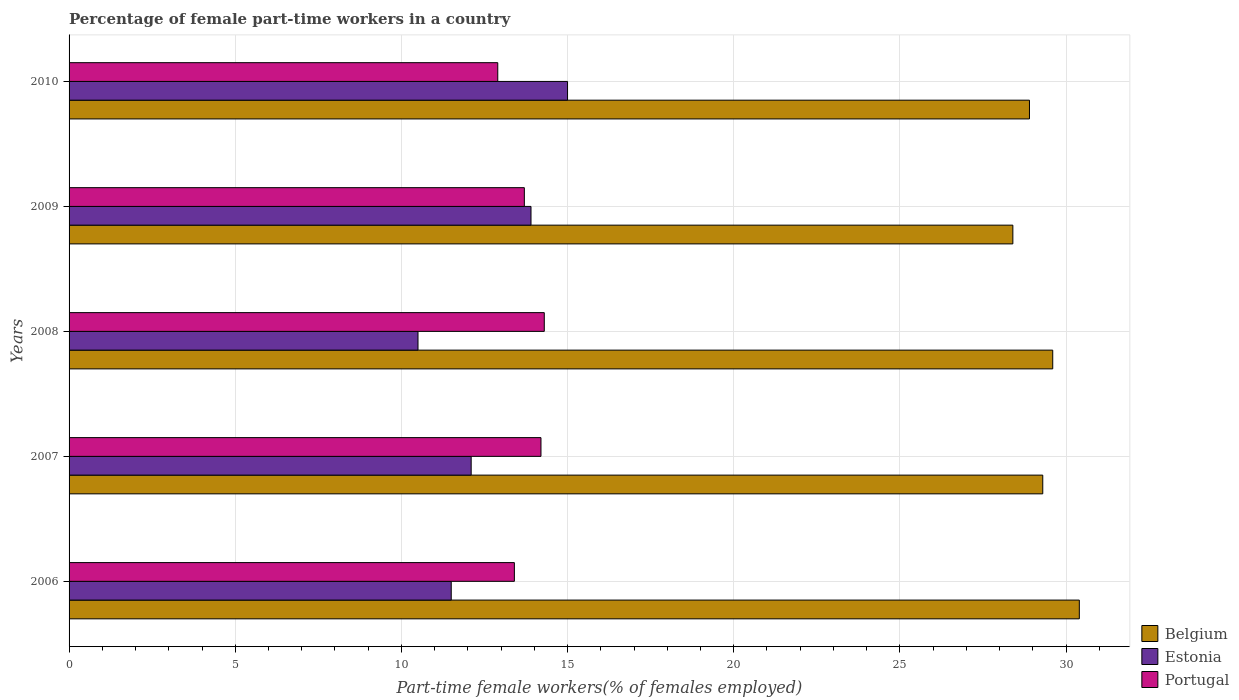Are the number of bars per tick equal to the number of legend labels?
Make the answer very short. Yes. Are the number of bars on each tick of the Y-axis equal?
Your answer should be compact. Yes. How many bars are there on the 1st tick from the bottom?
Give a very brief answer. 3. What is the percentage of female part-time workers in Portugal in 2010?
Your response must be concise. 12.9. Across all years, what is the maximum percentage of female part-time workers in Portugal?
Offer a terse response. 14.3. Across all years, what is the minimum percentage of female part-time workers in Portugal?
Your answer should be very brief. 12.9. In which year was the percentage of female part-time workers in Portugal maximum?
Provide a succinct answer. 2008. What is the total percentage of female part-time workers in Portugal in the graph?
Give a very brief answer. 68.5. What is the difference between the percentage of female part-time workers in Belgium in 2007 and that in 2010?
Offer a terse response. 0.4. What is the difference between the percentage of female part-time workers in Portugal in 2010 and the percentage of female part-time workers in Belgium in 2008?
Offer a terse response. -16.7. What is the average percentage of female part-time workers in Portugal per year?
Give a very brief answer. 13.7. In the year 2007, what is the difference between the percentage of female part-time workers in Portugal and percentage of female part-time workers in Estonia?
Your response must be concise. 2.1. What is the ratio of the percentage of female part-time workers in Estonia in 2007 to that in 2009?
Provide a short and direct response. 0.87. Is the percentage of female part-time workers in Estonia in 2008 less than that in 2009?
Your answer should be compact. Yes. Is the difference between the percentage of female part-time workers in Portugal in 2006 and 2009 greater than the difference between the percentage of female part-time workers in Estonia in 2006 and 2009?
Provide a short and direct response. Yes. What is the difference between the highest and the second highest percentage of female part-time workers in Estonia?
Offer a terse response. 1.1. What is the difference between the highest and the lowest percentage of female part-time workers in Portugal?
Your response must be concise. 1.4. What does the 1st bar from the top in 2008 represents?
Keep it short and to the point. Portugal. What does the 1st bar from the bottom in 2006 represents?
Provide a succinct answer. Belgium. Is it the case that in every year, the sum of the percentage of female part-time workers in Belgium and percentage of female part-time workers in Estonia is greater than the percentage of female part-time workers in Portugal?
Offer a very short reply. Yes. How many bars are there?
Offer a terse response. 15. Are all the bars in the graph horizontal?
Ensure brevity in your answer.  Yes. How many years are there in the graph?
Offer a terse response. 5. What is the difference between two consecutive major ticks on the X-axis?
Offer a terse response. 5. Are the values on the major ticks of X-axis written in scientific E-notation?
Ensure brevity in your answer.  No. Does the graph contain grids?
Your response must be concise. Yes. How are the legend labels stacked?
Your response must be concise. Vertical. What is the title of the graph?
Your response must be concise. Percentage of female part-time workers in a country. What is the label or title of the X-axis?
Provide a succinct answer. Part-time female workers(% of females employed). What is the label or title of the Y-axis?
Give a very brief answer. Years. What is the Part-time female workers(% of females employed) of Belgium in 2006?
Your response must be concise. 30.4. What is the Part-time female workers(% of females employed) in Estonia in 2006?
Ensure brevity in your answer.  11.5. What is the Part-time female workers(% of females employed) in Portugal in 2006?
Your answer should be compact. 13.4. What is the Part-time female workers(% of females employed) of Belgium in 2007?
Your answer should be compact. 29.3. What is the Part-time female workers(% of females employed) of Estonia in 2007?
Make the answer very short. 12.1. What is the Part-time female workers(% of females employed) in Portugal in 2007?
Offer a terse response. 14.2. What is the Part-time female workers(% of females employed) in Belgium in 2008?
Provide a succinct answer. 29.6. What is the Part-time female workers(% of females employed) of Portugal in 2008?
Your response must be concise. 14.3. What is the Part-time female workers(% of females employed) of Belgium in 2009?
Provide a succinct answer. 28.4. What is the Part-time female workers(% of females employed) in Estonia in 2009?
Provide a short and direct response. 13.9. What is the Part-time female workers(% of females employed) in Portugal in 2009?
Offer a very short reply. 13.7. What is the Part-time female workers(% of females employed) in Belgium in 2010?
Offer a terse response. 28.9. What is the Part-time female workers(% of females employed) of Estonia in 2010?
Offer a very short reply. 15. What is the Part-time female workers(% of females employed) of Portugal in 2010?
Ensure brevity in your answer.  12.9. Across all years, what is the maximum Part-time female workers(% of females employed) in Belgium?
Ensure brevity in your answer.  30.4. Across all years, what is the maximum Part-time female workers(% of females employed) in Portugal?
Give a very brief answer. 14.3. Across all years, what is the minimum Part-time female workers(% of females employed) of Belgium?
Provide a short and direct response. 28.4. Across all years, what is the minimum Part-time female workers(% of females employed) in Estonia?
Offer a terse response. 10.5. Across all years, what is the minimum Part-time female workers(% of females employed) of Portugal?
Offer a very short reply. 12.9. What is the total Part-time female workers(% of females employed) in Belgium in the graph?
Your answer should be compact. 146.6. What is the total Part-time female workers(% of females employed) in Portugal in the graph?
Give a very brief answer. 68.5. What is the difference between the Part-time female workers(% of females employed) in Belgium in 2006 and that in 2007?
Offer a terse response. 1.1. What is the difference between the Part-time female workers(% of females employed) in Portugal in 2006 and that in 2007?
Ensure brevity in your answer.  -0.8. What is the difference between the Part-time female workers(% of females employed) in Belgium in 2006 and that in 2009?
Your answer should be compact. 2. What is the difference between the Part-time female workers(% of females employed) of Estonia in 2006 and that in 2009?
Keep it short and to the point. -2.4. What is the difference between the Part-time female workers(% of females employed) of Portugal in 2006 and that in 2009?
Your response must be concise. -0.3. What is the difference between the Part-time female workers(% of females employed) in Portugal in 2006 and that in 2010?
Give a very brief answer. 0.5. What is the difference between the Part-time female workers(% of females employed) in Estonia in 2007 and that in 2009?
Your answer should be compact. -1.8. What is the difference between the Part-time female workers(% of females employed) in Belgium in 2008 and that in 2009?
Offer a terse response. 1.2. What is the difference between the Part-time female workers(% of females employed) in Estonia in 2008 and that in 2009?
Your response must be concise. -3.4. What is the difference between the Part-time female workers(% of females employed) in Belgium in 2008 and that in 2010?
Provide a succinct answer. 0.7. What is the difference between the Part-time female workers(% of females employed) in Estonia in 2008 and that in 2010?
Make the answer very short. -4.5. What is the difference between the Part-time female workers(% of females employed) of Portugal in 2008 and that in 2010?
Offer a very short reply. 1.4. What is the difference between the Part-time female workers(% of females employed) in Belgium in 2009 and that in 2010?
Offer a terse response. -0.5. What is the difference between the Part-time female workers(% of females employed) of Portugal in 2009 and that in 2010?
Provide a succinct answer. 0.8. What is the difference between the Part-time female workers(% of females employed) in Belgium in 2006 and the Part-time female workers(% of females employed) in Estonia in 2007?
Offer a very short reply. 18.3. What is the difference between the Part-time female workers(% of females employed) in Belgium in 2006 and the Part-time female workers(% of females employed) in Portugal in 2007?
Offer a very short reply. 16.2. What is the difference between the Part-time female workers(% of females employed) in Estonia in 2006 and the Part-time female workers(% of females employed) in Portugal in 2007?
Keep it short and to the point. -2.7. What is the difference between the Part-time female workers(% of females employed) in Belgium in 2006 and the Part-time female workers(% of females employed) in Portugal in 2008?
Provide a short and direct response. 16.1. What is the difference between the Part-time female workers(% of females employed) in Estonia in 2006 and the Part-time female workers(% of females employed) in Portugal in 2008?
Offer a terse response. -2.8. What is the difference between the Part-time female workers(% of females employed) in Belgium in 2006 and the Part-time female workers(% of females employed) in Estonia in 2009?
Ensure brevity in your answer.  16.5. What is the difference between the Part-time female workers(% of females employed) in Estonia in 2006 and the Part-time female workers(% of females employed) in Portugal in 2009?
Keep it short and to the point. -2.2. What is the difference between the Part-time female workers(% of females employed) of Belgium in 2006 and the Part-time female workers(% of females employed) of Estonia in 2010?
Keep it short and to the point. 15.4. What is the difference between the Part-time female workers(% of females employed) of Estonia in 2006 and the Part-time female workers(% of females employed) of Portugal in 2010?
Give a very brief answer. -1.4. What is the difference between the Part-time female workers(% of females employed) in Belgium in 2007 and the Part-time female workers(% of females employed) in Portugal in 2008?
Your response must be concise. 15. What is the difference between the Part-time female workers(% of females employed) of Belgium in 2007 and the Part-time female workers(% of females employed) of Portugal in 2009?
Ensure brevity in your answer.  15.6. What is the difference between the Part-time female workers(% of females employed) in Belgium in 2007 and the Part-time female workers(% of females employed) in Portugal in 2010?
Your answer should be compact. 16.4. What is the difference between the Part-time female workers(% of females employed) in Estonia in 2008 and the Part-time female workers(% of females employed) in Portugal in 2010?
Provide a succinct answer. -2.4. What is the difference between the Part-time female workers(% of females employed) in Estonia in 2009 and the Part-time female workers(% of females employed) in Portugal in 2010?
Offer a terse response. 1. What is the average Part-time female workers(% of females employed) of Belgium per year?
Your answer should be compact. 29.32. What is the average Part-time female workers(% of females employed) in Estonia per year?
Ensure brevity in your answer.  12.6. What is the average Part-time female workers(% of females employed) of Portugal per year?
Your response must be concise. 13.7. In the year 2006, what is the difference between the Part-time female workers(% of females employed) in Belgium and Part-time female workers(% of females employed) in Estonia?
Your response must be concise. 18.9. In the year 2006, what is the difference between the Part-time female workers(% of females employed) of Estonia and Part-time female workers(% of females employed) of Portugal?
Your answer should be very brief. -1.9. In the year 2007, what is the difference between the Part-time female workers(% of females employed) of Belgium and Part-time female workers(% of females employed) of Portugal?
Your response must be concise. 15.1. In the year 2007, what is the difference between the Part-time female workers(% of females employed) in Estonia and Part-time female workers(% of females employed) in Portugal?
Your answer should be compact. -2.1. In the year 2009, what is the difference between the Part-time female workers(% of females employed) in Belgium and Part-time female workers(% of females employed) in Estonia?
Your answer should be very brief. 14.5. In the year 2009, what is the difference between the Part-time female workers(% of females employed) of Estonia and Part-time female workers(% of females employed) of Portugal?
Give a very brief answer. 0.2. In the year 2010, what is the difference between the Part-time female workers(% of females employed) in Belgium and Part-time female workers(% of females employed) in Estonia?
Offer a terse response. 13.9. In the year 2010, what is the difference between the Part-time female workers(% of females employed) of Estonia and Part-time female workers(% of females employed) of Portugal?
Provide a short and direct response. 2.1. What is the ratio of the Part-time female workers(% of females employed) in Belgium in 2006 to that in 2007?
Provide a short and direct response. 1.04. What is the ratio of the Part-time female workers(% of females employed) of Estonia in 2006 to that in 2007?
Provide a succinct answer. 0.95. What is the ratio of the Part-time female workers(% of females employed) of Portugal in 2006 to that in 2007?
Your answer should be compact. 0.94. What is the ratio of the Part-time female workers(% of females employed) of Estonia in 2006 to that in 2008?
Provide a succinct answer. 1.1. What is the ratio of the Part-time female workers(% of females employed) of Portugal in 2006 to that in 2008?
Provide a short and direct response. 0.94. What is the ratio of the Part-time female workers(% of females employed) of Belgium in 2006 to that in 2009?
Offer a terse response. 1.07. What is the ratio of the Part-time female workers(% of females employed) in Estonia in 2006 to that in 2009?
Offer a very short reply. 0.83. What is the ratio of the Part-time female workers(% of females employed) in Portugal in 2006 to that in 2009?
Your response must be concise. 0.98. What is the ratio of the Part-time female workers(% of females employed) in Belgium in 2006 to that in 2010?
Provide a short and direct response. 1.05. What is the ratio of the Part-time female workers(% of females employed) in Estonia in 2006 to that in 2010?
Make the answer very short. 0.77. What is the ratio of the Part-time female workers(% of females employed) of Portugal in 2006 to that in 2010?
Provide a short and direct response. 1.04. What is the ratio of the Part-time female workers(% of females employed) of Estonia in 2007 to that in 2008?
Keep it short and to the point. 1.15. What is the ratio of the Part-time female workers(% of females employed) in Belgium in 2007 to that in 2009?
Your answer should be very brief. 1.03. What is the ratio of the Part-time female workers(% of females employed) of Estonia in 2007 to that in 2009?
Provide a short and direct response. 0.87. What is the ratio of the Part-time female workers(% of females employed) in Portugal in 2007 to that in 2009?
Your answer should be compact. 1.04. What is the ratio of the Part-time female workers(% of females employed) of Belgium in 2007 to that in 2010?
Keep it short and to the point. 1.01. What is the ratio of the Part-time female workers(% of females employed) of Estonia in 2007 to that in 2010?
Give a very brief answer. 0.81. What is the ratio of the Part-time female workers(% of females employed) of Portugal in 2007 to that in 2010?
Make the answer very short. 1.1. What is the ratio of the Part-time female workers(% of females employed) in Belgium in 2008 to that in 2009?
Your response must be concise. 1.04. What is the ratio of the Part-time female workers(% of females employed) in Estonia in 2008 to that in 2009?
Provide a succinct answer. 0.76. What is the ratio of the Part-time female workers(% of females employed) of Portugal in 2008 to that in 2009?
Your answer should be compact. 1.04. What is the ratio of the Part-time female workers(% of females employed) in Belgium in 2008 to that in 2010?
Your answer should be very brief. 1.02. What is the ratio of the Part-time female workers(% of females employed) of Estonia in 2008 to that in 2010?
Give a very brief answer. 0.7. What is the ratio of the Part-time female workers(% of females employed) of Portugal in 2008 to that in 2010?
Offer a very short reply. 1.11. What is the ratio of the Part-time female workers(% of females employed) in Belgium in 2009 to that in 2010?
Keep it short and to the point. 0.98. What is the ratio of the Part-time female workers(% of females employed) in Estonia in 2009 to that in 2010?
Your answer should be very brief. 0.93. What is the ratio of the Part-time female workers(% of females employed) in Portugal in 2009 to that in 2010?
Keep it short and to the point. 1.06. What is the difference between the highest and the second highest Part-time female workers(% of females employed) of Estonia?
Your answer should be compact. 1.1. What is the difference between the highest and the second highest Part-time female workers(% of females employed) in Portugal?
Offer a terse response. 0.1. What is the difference between the highest and the lowest Part-time female workers(% of females employed) in Belgium?
Your answer should be compact. 2. 